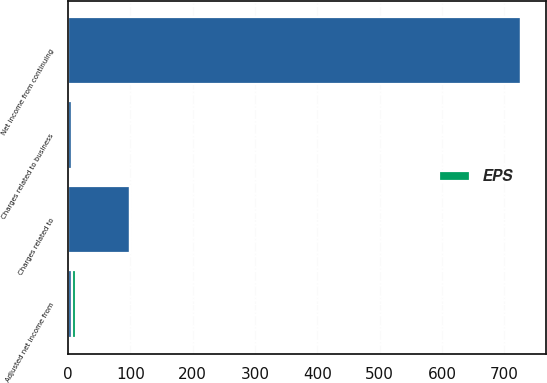<chart> <loc_0><loc_0><loc_500><loc_500><stacked_bar_chart><ecel><fcel>Net income from continuing<fcel>Charges related to business<fcel>Charges related to<fcel>Adjusted net income from<nl><fcel>nan<fcel>726<fcel>7<fcel>99<fcel>6.44<nl><fcel>EPS<fcel>4.69<fcel>0.05<fcel>0.64<fcel>6.44<nl></chart> 